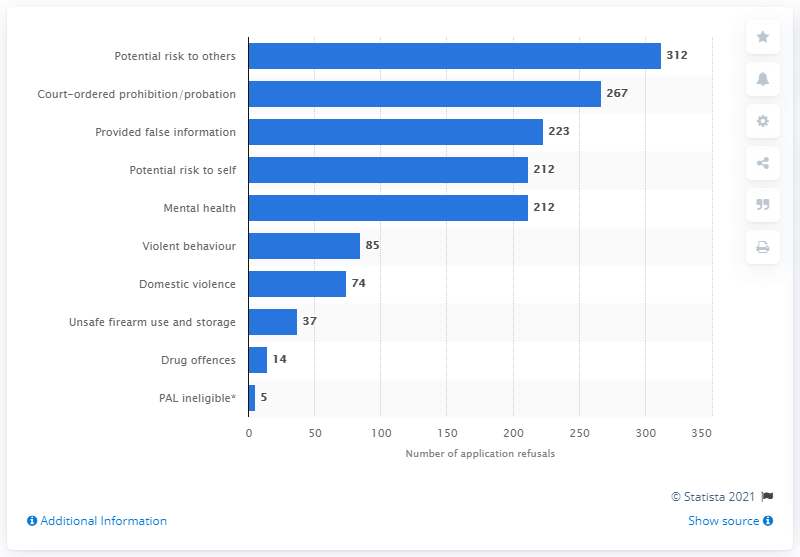Draw attention to some important aspects in this diagram. There were 74 firearms license application refusals in Canada in 2019. 